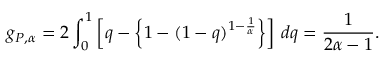<formula> <loc_0><loc_0><loc_500><loc_500>g _ { P , \alpha } = 2 \int _ { 0 } ^ { 1 } \left [ q - \left \{ 1 - ( 1 - q ) ^ { 1 - \frac { 1 } { \alpha } } \right \} \right ] \, d q = \frac { 1 } { 2 \alpha - 1 } .</formula> 